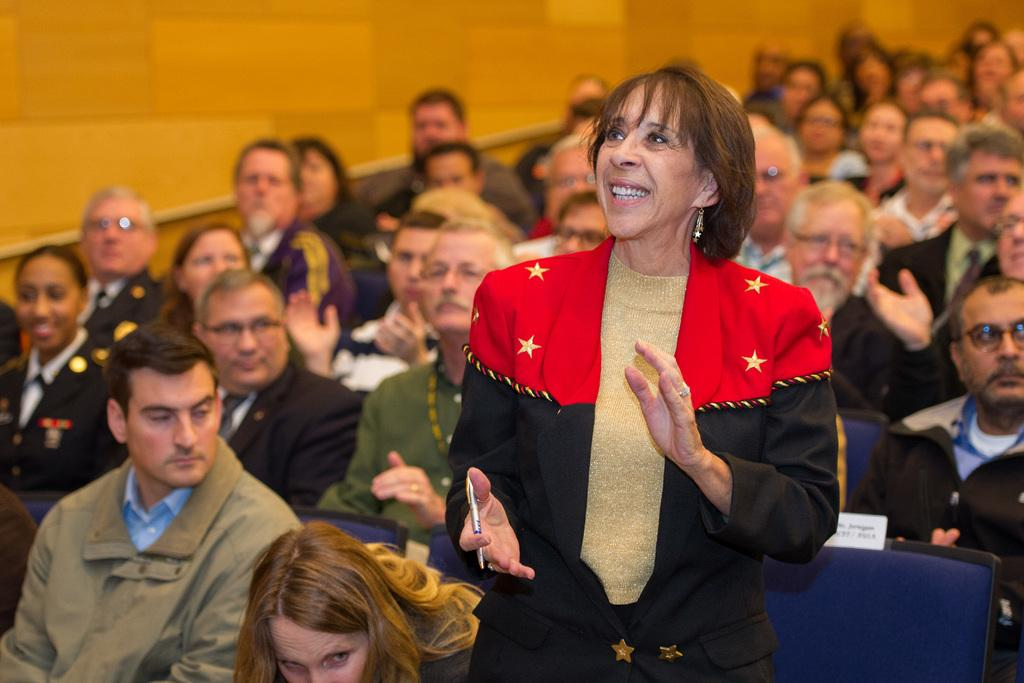What are the people in the image doing? The people in the image are sitting on chairs. Can you describe the woman in the image? There is a woman standing among the people, and she is smiling. What is the woman holding in her hand? The woman is holding an object in her hand. What can be seen in the background of the image? There is a wall visible in the image. What type of hair can be seen on the star in the image? There is no star present in the image, and therefore no hair can be observed on it. 